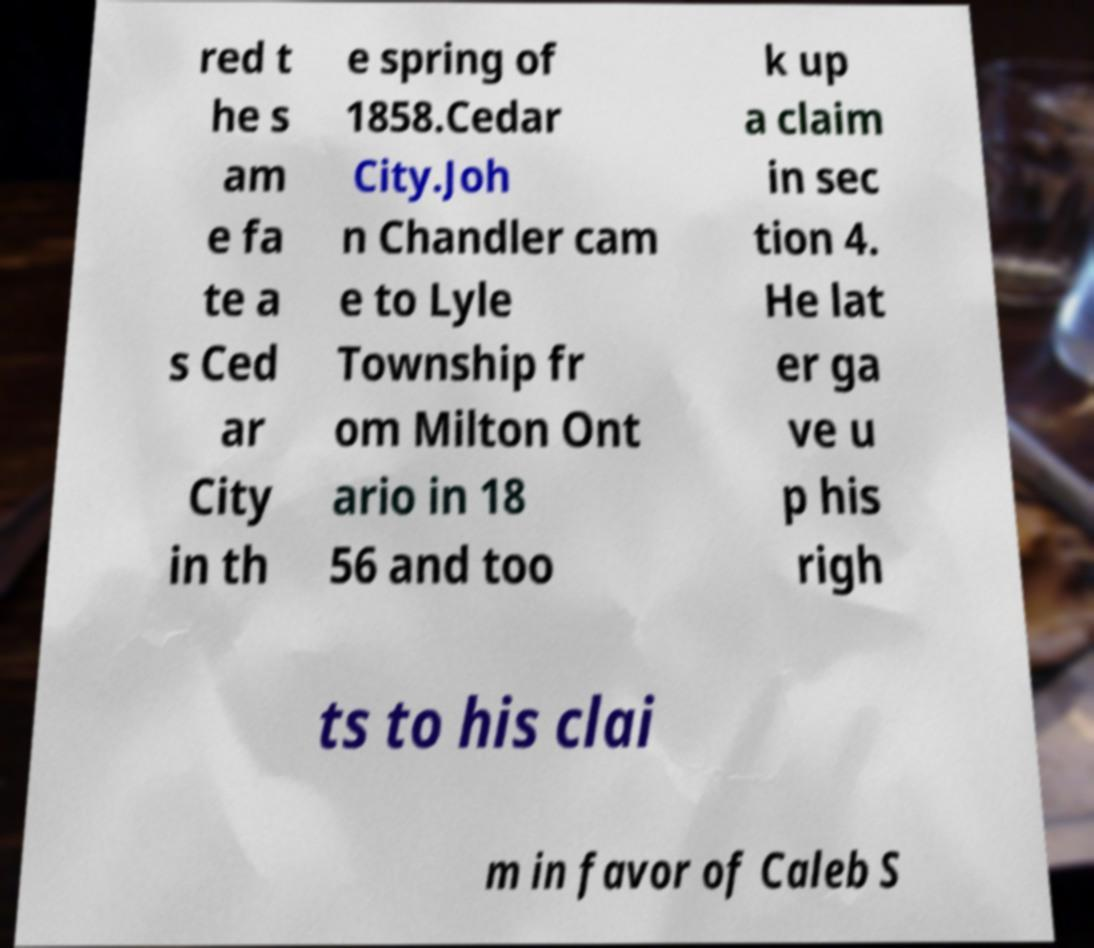Please read and relay the text visible in this image. What does it say? red t he s am e fa te a s Ced ar City in th e spring of 1858.Cedar City.Joh n Chandler cam e to Lyle Township fr om Milton Ont ario in 18 56 and too k up a claim in sec tion 4. He lat er ga ve u p his righ ts to his clai m in favor of Caleb S 